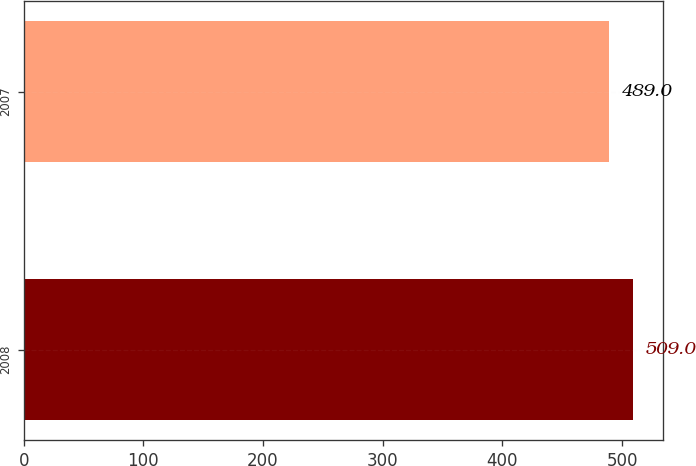Convert chart to OTSL. <chart><loc_0><loc_0><loc_500><loc_500><bar_chart><fcel>2008<fcel>2007<nl><fcel>509<fcel>489<nl></chart> 